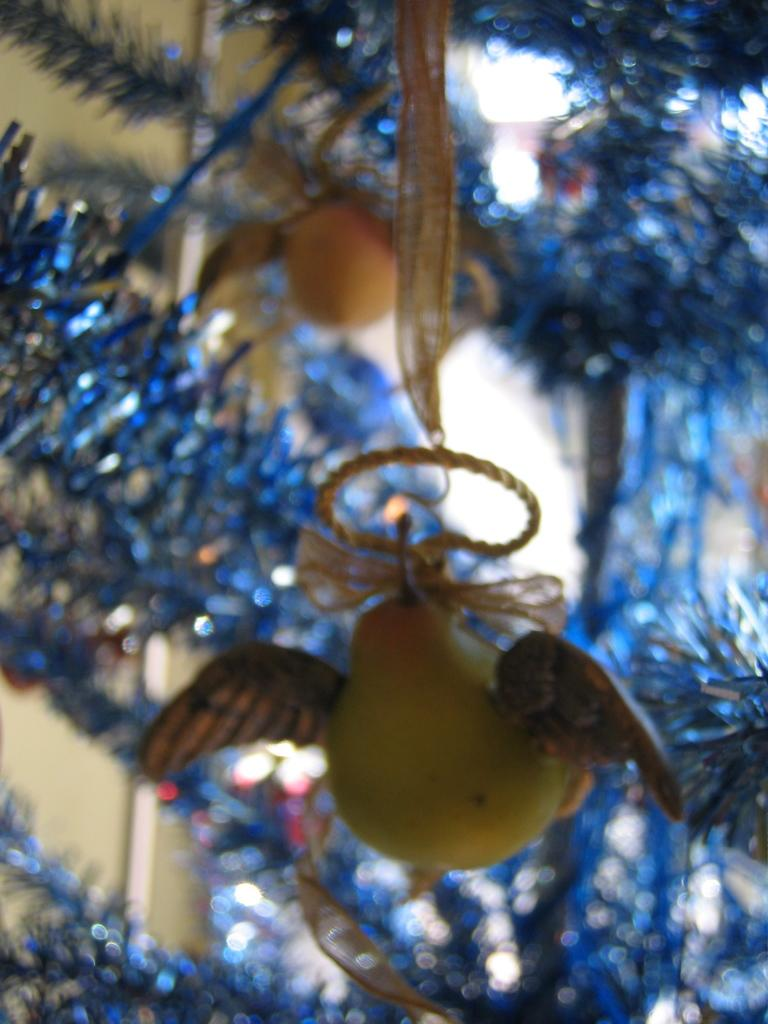What type of tree is in the image? There is a Christmas tree in the image. How is the Christmas tree decorated? The Christmas tree is decorated. What is the unusual object hanging in front of the Christmas tree? There is a fruit with wings in the image. What type of bait is used to catch fish in the image? There is no mention of fishing or bait in the image, as it features a Christmas tree and a fruit with wings. 